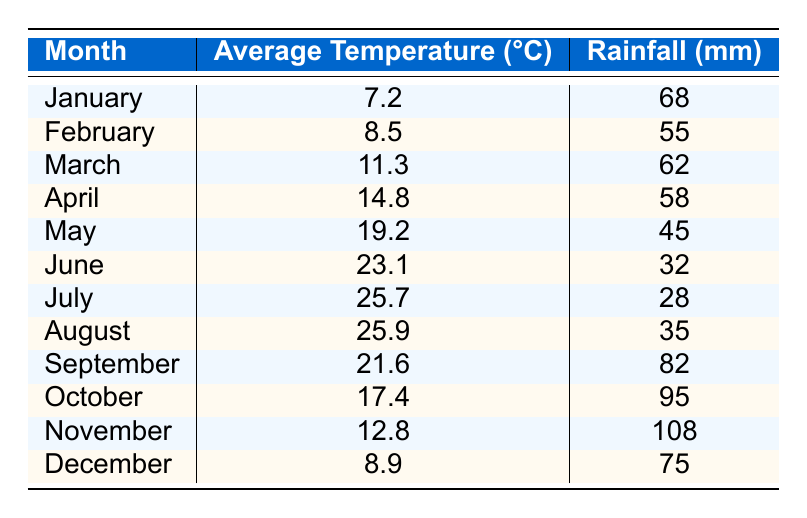What is the average temperature in July? The table shows that the average temperature in July is listed under the respective month, which is 25.7°C.
Answer: 25.7°C Which month had the highest rainfall? By comparing the rainfall values for each month, November has the highest value at 108 mm of rainfall.
Answer: November What is the average rainfall over the year? To find the average rainfall, add all the rainfall values (68 + 55 + 62 + 58 + 45 + 32 + 28 + 35 + 82 + 95 + 108 + 75 = 743) and divide by the number of months (12), which equals 743 / 12 = 61.92 mm.
Answer: 61.92 mm Did the temperature drop below 10°C in any month? By checking the average temperatures, January (7.2°C) and February (8.5°C) both fell below 10°C.
Answer: Yes How much more rainfall occurred in October compared to June? The rainfall in October is 95 mm and in June it is 32 mm. The difference is 95 - 32 = 63 mm.
Answer: 63 mm In which month does the average temperature start to exceed 20°C? From the table, the average temperature exceeds 20°C starting in June (23.1°C).
Answer: June What is the total rainfall from May to August? Add the monthly rainfall values from May (45 mm), June (32 mm), July (28 mm), and August (35 mm), which totals 45 + 32 + 28 + 35 = 140 mm.
Answer: 140 mm Is the average temperature in October greater than the average in September? The average temperature in October is 17.4°C while in September it is 21.6°C. Since 17.4°C is less than 21.6°C, the statement is false.
Answer: No Which month has the closest average temperature to 20°C? Comparing the average temperatures, May (19.2°C) is the closest to 20°C as it is only 0.8°C less.
Answer: May What is the median average temperature for the year? Arranging the monthly temperatures in order (7.2, 8.5, 11.3, 12.8, 14.8, 17.4, 19.2, 21.6, 23.1, 25.7, 25.9, 8.9) gives the middle values of 17.4°C and 19.2°C. The median is the average of these two: (17.4 + 19.2) / 2 = 18.3°C.
Answer: 18.3°C 